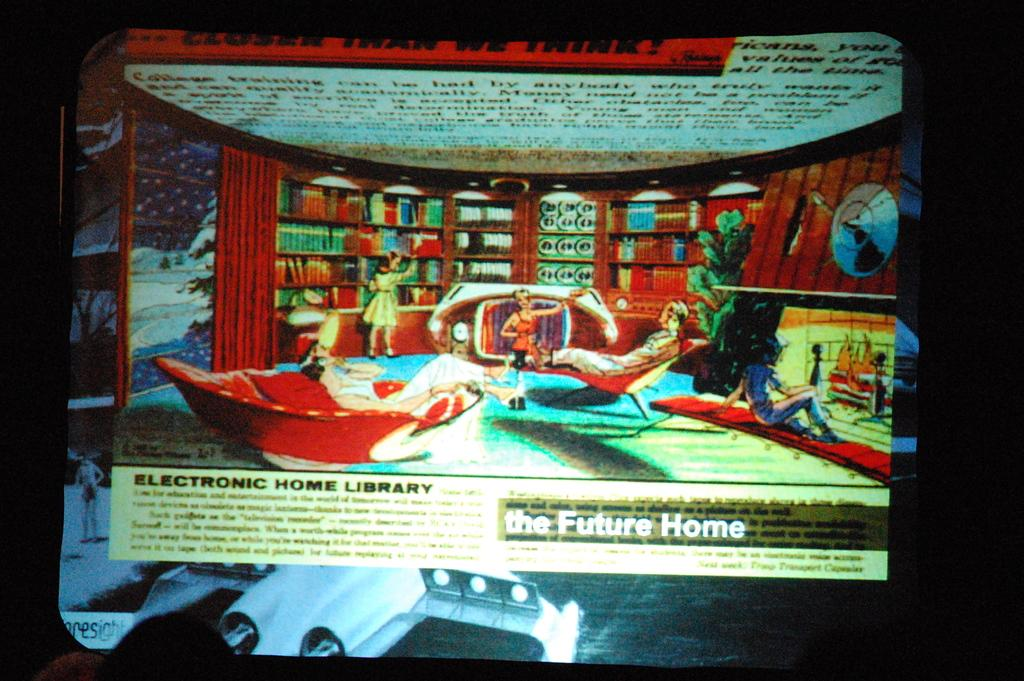What is the overall lighting condition in the image? The image is dark. What can be seen on the screen in the image? People are visible on the screen. What type of goose is being discussed in the letter on the screen? There is no letter or goose present in the image; it only shows a screen with people visible. 